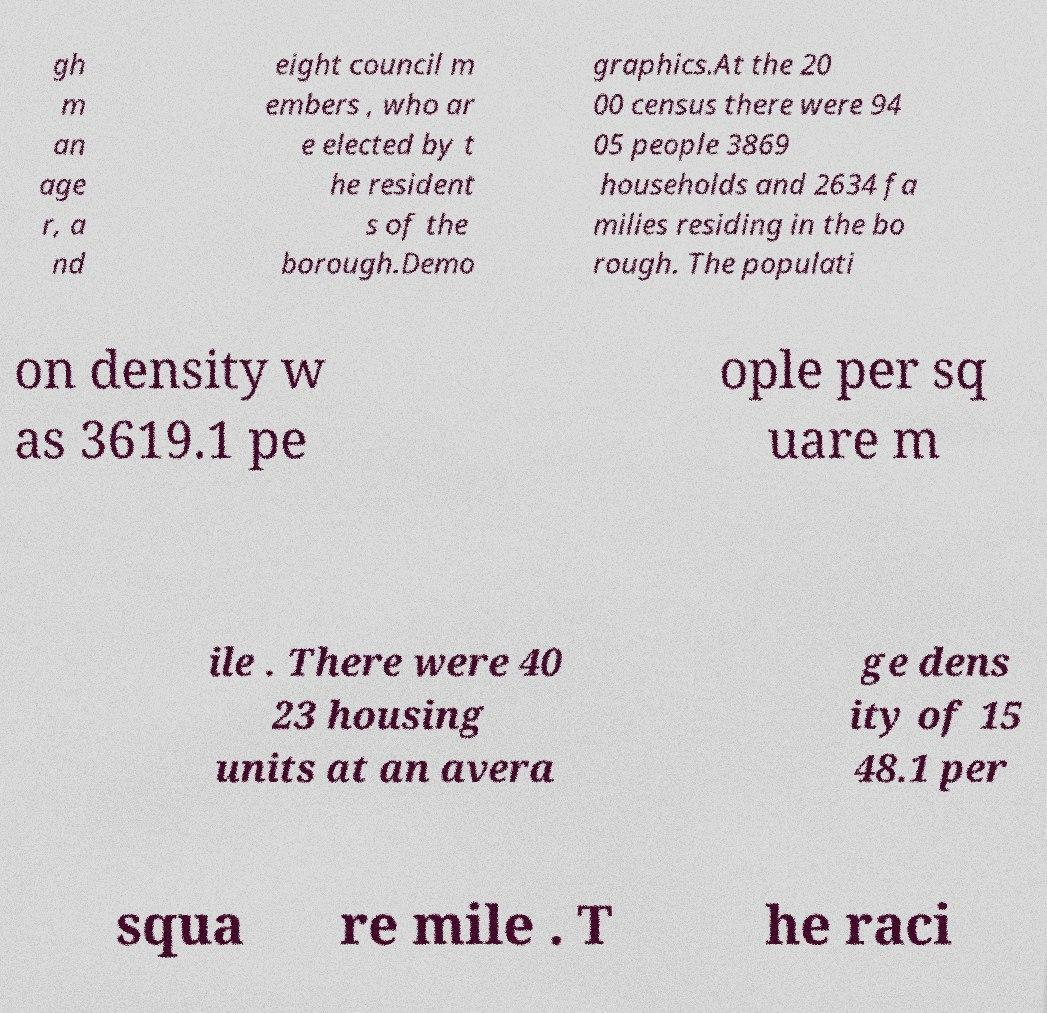Can you read and provide the text displayed in the image?This photo seems to have some interesting text. Can you extract and type it out for me? gh m an age r, a nd eight council m embers , who ar e elected by t he resident s of the borough.Demo graphics.At the 20 00 census there were 94 05 people 3869 households and 2634 fa milies residing in the bo rough. The populati on density w as 3619.1 pe ople per sq uare m ile . There were 40 23 housing units at an avera ge dens ity of 15 48.1 per squa re mile . T he raci 